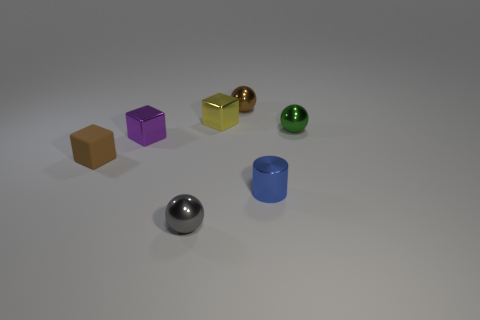There is a gray metallic thing that is the same size as the rubber object; what is its shape? The gray metallic object has a spherical shape, similar in size to the green rubber ball adjacent to it. 